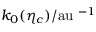<formula> <loc_0><loc_0><loc_500><loc_500>k _ { 0 } ( \eta _ { c } ) / { a u } \, ^ { - 1 }</formula> 